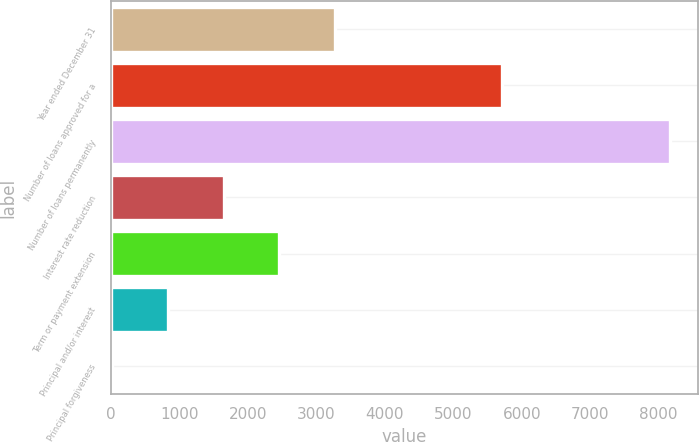<chart> <loc_0><loc_0><loc_500><loc_500><bar_chart><fcel>Year ended December 31<fcel>Number of loans approved for a<fcel>Number of loans permanently<fcel>Interest rate reduction<fcel>Term or payment extension<fcel>Principal and/or interest<fcel>Principal forgiveness<nl><fcel>3274.4<fcel>5705<fcel>8162<fcel>1645.2<fcel>2459.8<fcel>830.6<fcel>16<nl></chart> 